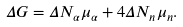<formula> <loc_0><loc_0><loc_500><loc_500>\Delta G = \Delta N _ { \alpha } \mu _ { \alpha } + 4 \Delta N _ { n } \mu _ { n } .</formula> 